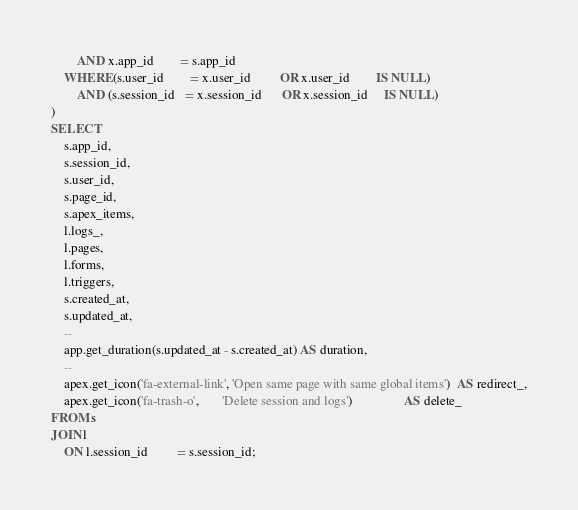Convert code to text. <code><loc_0><loc_0><loc_500><loc_500><_SQL_>        AND x.app_id        = s.app_id
    WHERE (s.user_id        = x.user_id         OR x.user_id        IS NULL)
        AND (s.session_id   = x.session_id      OR x.session_id     IS NULL)
)
SELECT
    s.app_id,
    s.session_id,
    s.user_id,
    s.page_id,
    s.apex_items,
    l.logs_,
    l.pages,
    l.forms,
    l.triggers,
    s.created_at,
    s.updated_at,
    --
    app.get_duration(s.updated_at - s.created_at) AS duration,
    --
    apex.get_icon('fa-external-link', 'Open same page with same global items')  AS redirect_,
    apex.get_icon('fa-trash-o',       'Delete session and logs')                AS delete_
FROM s
JOIN l
    ON l.session_id         = s.session_id;

</code> 